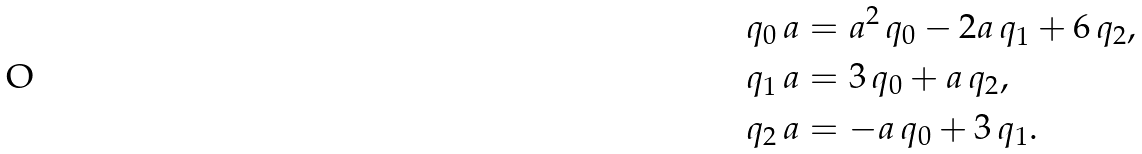Convert formula to latex. <formula><loc_0><loc_0><loc_500><loc_500>q _ { 0 } \, a & = a ^ { 2 } \, q _ { 0 } - 2 a \, q _ { 1 } + 6 \, q _ { 2 } , \\ q _ { 1 } \, a & = 3 \, q _ { 0 } + a \, q _ { 2 } , \\ q _ { 2 } \, a & = - a \, q _ { 0 } + 3 \, q _ { 1 } .</formula> 